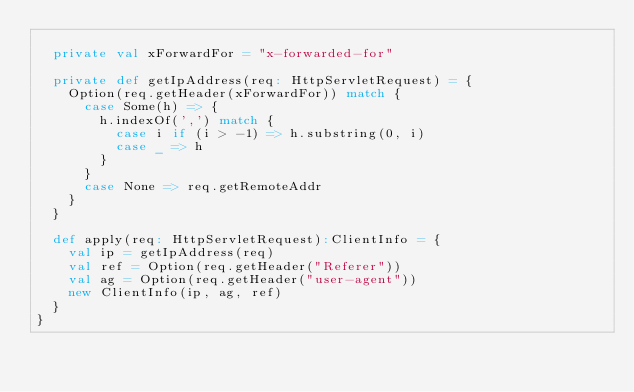Convert code to text. <code><loc_0><loc_0><loc_500><loc_500><_Scala_>
  private val xForwardFor = "x-forwarded-for"

  private def getIpAddress(req: HttpServletRequest) = {
    Option(req.getHeader(xForwardFor)) match {
      case Some(h) => {
        h.indexOf(',') match {
          case i if (i > -1) => h.substring(0, i)
          case _ => h
        }
      }
      case None => req.getRemoteAddr
    }
  }

  def apply(req: HttpServletRequest):ClientInfo = {
    val ip = getIpAddress(req)
    val ref = Option(req.getHeader("Referer"))
    val ag = Option(req.getHeader("user-agent"))
    new ClientInfo(ip, ag, ref)
  }
}
</code> 